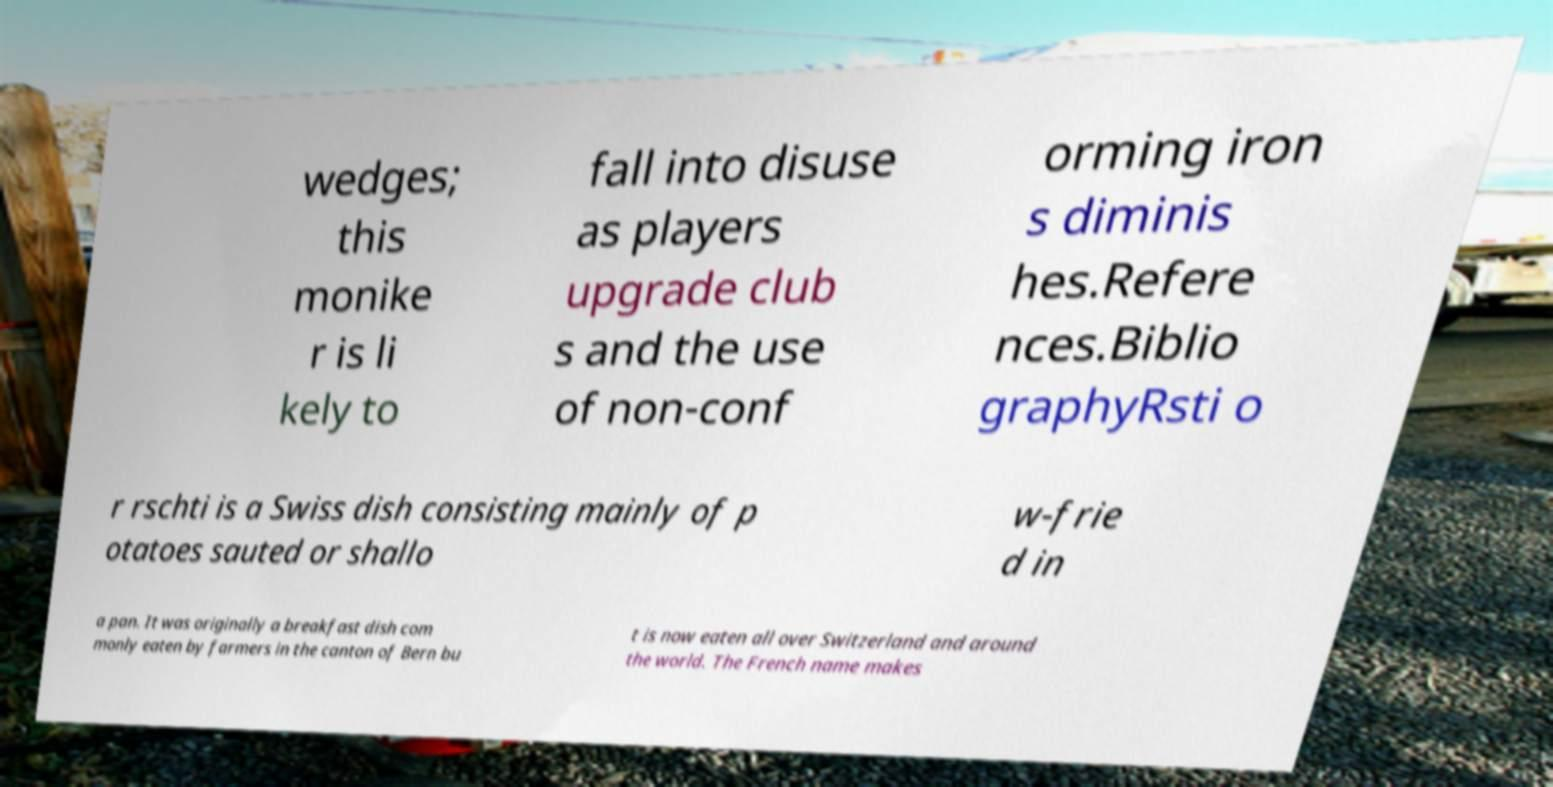Could you extract and type out the text from this image? wedges; this monike r is li kely to fall into disuse as players upgrade club s and the use of non-conf orming iron s diminis hes.Refere nces.Biblio graphyRsti o r rschti is a Swiss dish consisting mainly of p otatoes sauted or shallo w-frie d in a pan. It was originally a breakfast dish com monly eaten by farmers in the canton of Bern bu t is now eaten all over Switzerland and around the world. The French name makes 